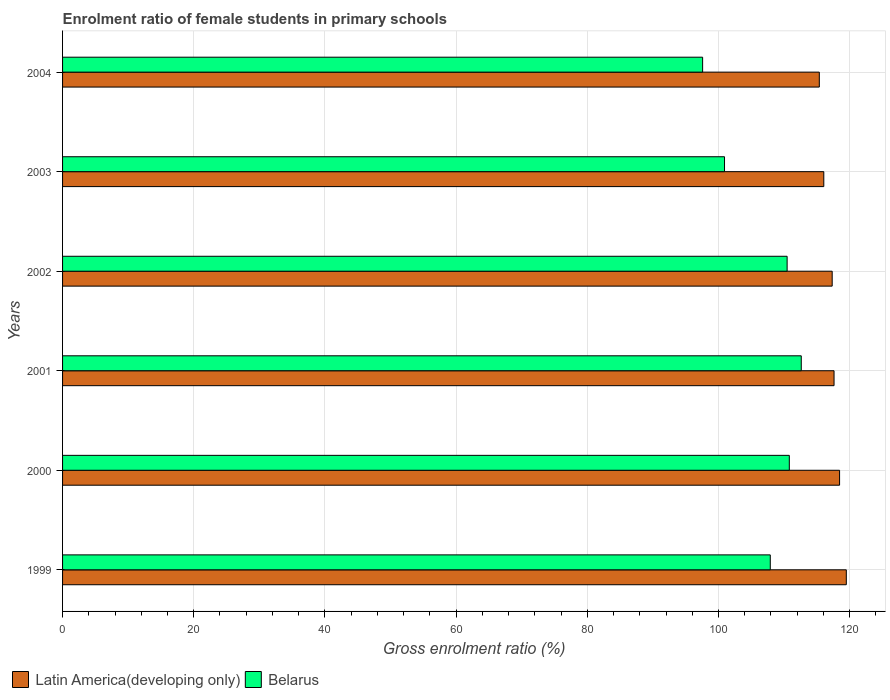Are the number of bars on each tick of the Y-axis equal?
Make the answer very short. Yes. How many bars are there on the 2nd tick from the bottom?
Keep it short and to the point. 2. What is the label of the 2nd group of bars from the top?
Your answer should be compact. 2003. In how many cases, is the number of bars for a given year not equal to the number of legend labels?
Your response must be concise. 0. What is the enrolment ratio of female students in primary schools in Belarus in 2003?
Keep it short and to the point. 100.92. Across all years, what is the maximum enrolment ratio of female students in primary schools in Belarus?
Provide a succinct answer. 112.62. Across all years, what is the minimum enrolment ratio of female students in primary schools in Latin America(developing only)?
Ensure brevity in your answer.  115.37. What is the total enrolment ratio of female students in primary schools in Latin America(developing only) in the graph?
Provide a succinct answer. 704.31. What is the difference between the enrolment ratio of female students in primary schools in Latin America(developing only) in 2000 and that in 2002?
Give a very brief answer. 1.13. What is the difference between the enrolment ratio of female students in primary schools in Belarus in 2004 and the enrolment ratio of female students in primary schools in Latin America(developing only) in 1999?
Give a very brief answer. -21.9. What is the average enrolment ratio of female students in primary schools in Belarus per year?
Your response must be concise. 106.71. In the year 2001, what is the difference between the enrolment ratio of female students in primary schools in Latin America(developing only) and enrolment ratio of female students in primary schools in Belarus?
Keep it short and to the point. 5. What is the ratio of the enrolment ratio of female students in primary schools in Belarus in 1999 to that in 2003?
Make the answer very short. 1.07. Is the difference between the enrolment ratio of female students in primary schools in Latin America(developing only) in 1999 and 2003 greater than the difference between the enrolment ratio of female students in primary schools in Belarus in 1999 and 2003?
Your answer should be compact. No. What is the difference between the highest and the second highest enrolment ratio of female students in primary schools in Belarus?
Your answer should be very brief. 1.82. What is the difference between the highest and the lowest enrolment ratio of female students in primary schools in Belarus?
Your response must be concise. 15.04. Is the sum of the enrolment ratio of female students in primary schools in Latin America(developing only) in 2000 and 2002 greater than the maximum enrolment ratio of female students in primary schools in Belarus across all years?
Keep it short and to the point. Yes. What does the 1st bar from the top in 2003 represents?
Provide a succinct answer. Belarus. What does the 2nd bar from the bottom in 2001 represents?
Your answer should be very brief. Belarus. How many years are there in the graph?
Provide a short and direct response. 6. Does the graph contain any zero values?
Provide a succinct answer. No. Where does the legend appear in the graph?
Your answer should be very brief. Bottom left. What is the title of the graph?
Your response must be concise. Enrolment ratio of female students in primary schools. What is the label or title of the X-axis?
Provide a short and direct response. Gross enrolment ratio (%). What is the label or title of the Y-axis?
Ensure brevity in your answer.  Years. What is the Gross enrolment ratio (%) in Latin America(developing only) in 1999?
Your response must be concise. 119.48. What is the Gross enrolment ratio (%) of Belarus in 1999?
Your answer should be very brief. 107.89. What is the Gross enrolment ratio (%) in Latin America(developing only) in 2000?
Offer a terse response. 118.46. What is the Gross enrolment ratio (%) in Belarus in 2000?
Make the answer very short. 110.8. What is the Gross enrolment ratio (%) in Latin America(developing only) in 2001?
Ensure brevity in your answer.  117.61. What is the Gross enrolment ratio (%) of Belarus in 2001?
Provide a succinct answer. 112.62. What is the Gross enrolment ratio (%) of Latin America(developing only) in 2002?
Ensure brevity in your answer.  117.33. What is the Gross enrolment ratio (%) in Belarus in 2002?
Give a very brief answer. 110.46. What is the Gross enrolment ratio (%) of Latin America(developing only) in 2003?
Offer a terse response. 116.05. What is the Gross enrolment ratio (%) of Belarus in 2003?
Ensure brevity in your answer.  100.92. What is the Gross enrolment ratio (%) in Latin America(developing only) in 2004?
Make the answer very short. 115.37. What is the Gross enrolment ratio (%) in Belarus in 2004?
Make the answer very short. 97.58. Across all years, what is the maximum Gross enrolment ratio (%) of Latin America(developing only)?
Offer a terse response. 119.48. Across all years, what is the maximum Gross enrolment ratio (%) in Belarus?
Make the answer very short. 112.62. Across all years, what is the minimum Gross enrolment ratio (%) of Latin America(developing only)?
Make the answer very short. 115.37. Across all years, what is the minimum Gross enrolment ratio (%) of Belarus?
Keep it short and to the point. 97.58. What is the total Gross enrolment ratio (%) of Latin America(developing only) in the graph?
Offer a terse response. 704.31. What is the total Gross enrolment ratio (%) in Belarus in the graph?
Give a very brief answer. 640.27. What is the difference between the Gross enrolment ratio (%) of Latin America(developing only) in 1999 and that in 2000?
Make the answer very short. 1.03. What is the difference between the Gross enrolment ratio (%) of Belarus in 1999 and that in 2000?
Provide a succinct answer. -2.9. What is the difference between the Gross enrolment ratio (%) in Latin America(developing only) in 1999 and that in 2001?
Provide a short and direct response. 1.87. What is the difference between the Gross enrolment ratio (%) in Belarus in 1999 and that in 2001?
Your response must be concise. -4.72. What is the difference between the Gross enrolment ratio (%) in Latin America(developing only) in 1999 and that in 2002?
Your answer should be very brief. 2.15. What is the difference between the Gross enrolment ratio (%) in Belarus in 1999 and that in 2002?
Keep it short and to the point. -2.57. What is the difference between the Gross enrolment ratio (%) of Latin America(developing only) in 1999 and that in 2003?
Give a very brief answer. 3.43. What is the difference between the Gross enrolment ratio (%) in Belarus in 1999 and that in 2003?
Keep it short and to the point. 6.98. What is the difference between the Gross enrolment ratio (%) in Latin America(developing only) in 1999 and that in 2004?
Provide a short and direct response. 4.12. What is the difference between the Gross enrolment ratio (%) in Belarus in 1999 and that in 2004?
Ensure brevity in your answer.  10.31. What is the difference between the Gross enrolment ratio (%) in Latin America(developing only) in 2000 and that in 2001?
Provide a short and direct response. 0.84. What is the difference between the Gross enrolment ratio (%) in Belarus in 2000 and that in 2001?
Offer a terse response. -1.82. What is the difference between the Gross enrolment ratio (%) of Latin America(developing only) in 2000 and that in 2002?
Offer a very short reply. 1.13. What is the difference between the Gross enrolment ratio (%) in Belarus in 2000 and that in 2002?
Give a very brief answer. 0.34. What is the difference between the Gross enrolment ratio (%) in Latin America(developing only) in 2000 and that in 2003?
Give a very brief answer. 2.4. What is the difference between the Gross enrolment ratio (%) of Belarus in 2000 and that in 2003?
Ensure brevity in your answer.  9.88. What is the difference between the Gross enrolment ratio (%) of Latin America(developing only) in 2000 and that in 2004?
Your answer should be very brief. 3.09. What is the difference between the Gross enrolment ratio (%) in Belarus in 2000 and that in 2004?
Your response must be concise. 13.22. What is the difference between the Gross enrolment ratio (%) of Latin America(developing only) in 2001 and that in 2002?
Provide a short and direct response. 0.28. What is the difference between the Gross enrolment ratio (%) in Belarus in 2001 and that in 2002?
Your response must be concise. 2.16. What is the difference between the Gross enrolment ratio (%) of Latin America(developing only) in 2001 and that in 2003?
Provide a succinct answer. 1.56. What is the difference between the Gross enrolment ratio (%) in Belarus in 2001 and that in 2003?
Ensure brevity in your answer.  11.7. What is the difference between the Gross enrolment ratio (%) of Latin America(developing only) in 2001 and that in 2004?
Offer a terse response. 2.25. What is the difference between the Gross enrolment ratio (%) in Belarus in 2001 and that in 2004?
Ensure brevity in your answer.  15.04. What is the difference between the Gross enrolment ratio (%) of Latin America(developing only) in 2002 and that in 2003?
Make the answer very short. 1.28. What is the difference between the Gross enrolment ratio (%) in Belarus in 2002 and that in 2003?
Provide a succinct answer. 9.54. What is the difference between the Gross enrolment ratio (%) of Latin America(developing only) in 2002 and that in 2004?
Your answer should be compact. 1.96. What is the difference between the Gross enrolment ratio (%) of Belarus in 2002 and that in 2004?
Provide a succinct answer. 12.88. What is the difference between the Gross enrolment ratio (%) of Latin America(developing only) in 2003 and that in 2004?
Provide a succinct answer. 0.68. What is the difference between the Gross enrolment ratio (%) in Belarus in 2003 and that in 2004?
Your answer should be very brief. 3.34. What is the difference between the Gross enrolment ratio (%) in Latin America(developing only) in 1999 and the Gross enrolment ratio (%) in Belarus in 2000?
Make the answer very short. 8.69. What is the difference between the Gross enrolment ratio (%) in Latin America(developing only) in 1999 and the Gross enrolment ratio (%) in Belarus in 2001?
Your response must be concise. 6.87. What is the difference between the Gross enrolment ratio (%) of Latin America(developing only) in 1999 and the Gross enrolment ratio (%) of Belarus in 2002?
Offer a terse response. 9.02. What is the difference between the Gross enrolment ratio (%) of Latin America(developing only) in 1999 and the Gross enrolment ratio (%) of Belarus in 2003?
Offer a very short reply. 18.57. What is the difference between the Gross enrolment ratio (%) of Latin America(developing only) in 1999 and the Gross enrolment ratio (%) of Belarus in 2004?
Your answer should be very brief. 21.9. What is the difference between the Gross enrolment ratio (%) in Latin America(developing only) in 2000 and the Gross enrolment ratio (%) in Belarus in 2001?
Give a very brief answer. 5.84. What is the difference between the Gross enrolment ratio (%) of Latin America(developing only) in 2000 and the Gross enrolment ratio (%) of Belarus in 2002?
Provide a succinct answer. 8. What is the difference between the Gross enrolment ratio (%) in Latin America(developing only) in 2000 and the Gross enrolment ratio (%) in Belarus in 2003?
Give a very brief answer. 17.54. What is the difference between the Gross enrolment ratio (%) in Latin America(developing only) in 2000 and the Gross enrolment ratio (%) in Belarus in 2004?
Make the answer very short. 20.88. What is the difference between the Gross enrolment ratio (%) of Latin America(developing only) in 2001 and the Gross enrolment ratio (%) of Belarus in 2002?
Your answer should be very brief. 7.15. What is the difference between the Gross enrolment ratio (%) in Latin America(developing only) in 2001 and the Gross enrolment ratio (%) in Belarus in 2003?
Ensure brevity in your answer.  16.7. What is the difference between the Gross enrolment ratio (%) of Latin America(developing only) in 2001 and the Gross enrolment ratio (%) of Belarus in 2004?
Provide a short and direct response. 20.03. What is the difference between the Gross enrolment ratio (%) in Latin America(developing only) in 2002 and the Gross enrolment ratio (%) in Belarus in 2003?
Your answer should be compact. 16.41. What is the difference between the Gross enrolment ratio (%) of Latin America(developing only) in 2002 and the Gross enrolment ratio (%) of Belarus in 2004?
Offer a very short reply. 19.75. What is the difference between the Gross enrolment ratio (%) in Latin America(developing only) in 2003 and the Gross enrolment ratio (%) in Belarus in 2004?
Make the answer very short. 18.47. What is the average Gross enrolment ratio (%) in Latin America(developing only) per year?
Keep it short and to the point. 117.39. What is the average Gross enrolment ratio (%) in Belarus per year?
Your answer should be very brief. 106.71. In the year 1999, what is the difference between the Gross enrolment ratio (%) in Latin America(developing only) and Gross enrolment ratio (%) in Belarus?
Offer a terse response. 11.59. In the year 2000, what is the difference between the Gross enrolment ratio (%) in Latin America(developing only) and Gross enrolment ratio (%) in Belarus?
Your answer should be compact. 7.66. In the year 2001, what is the difference between the Gross enrolment ratio (%) in Latin America(developing only) and Gross enrolment ratio (%) in Belarus?
Your response must be concise. 5. In the year 2002, what is the difference between the Gross enrolment ratio (%) of Latin America(developing only) and Gross enrolment ratio (%) of Belarus?
Provide a succinct answer. 6.87. In the year 2003, what is the difference between the Gross enrolment ratio (%) of Latin America(developing only) and Gross enrolment ratio (%) of Belarus?
Offer a terse response. 15.14. In the year 2004, what is the difference between the Gross enrolment ratio (%) of Latin America(developing only) and Gross enrolment ratio (%) of Belarus?
Your response must be concise. 17.79. What is the ratio of the Gross enrolment ratio (%) in Latin America(developing only) in 1999 to that in 2000?
Offer a very short reply. 1.01. What is the ratio of the Gross enrolment ratio (%) of Belarus in 1999 to that in 2000?
Your answer should be compact. 0.97. What is the ratio of the Gross enrolment ratio (%) of Latin America(developing only) in 1999 to that in 2001?
Offer a very short reply. 1.02. What is the ratio of the Gross enrolment ratio (%) in Belarus in 1999 to that in 2001?
Your answer should be compact. 0.96. What is the ratio of the Gross enrolment ratio (%) in Latin America(developing only) in 1999 to that in 2002?
Your response must be concise. 1.02. What is the ratio of the Gross enrolment ratio (%) in Belarus in 1999 to that in 2002?
Offer a very short reply. 0.98. What is the ratio of the Gross enrolment ratio (%) in Latin America(developing only) in 1999 to that in 2003?
Provide a short and direct response. 1.03. What is the ratio of the Gross enrolment ratio (%) of Belarus in 1999 to that in 2003?
Your response must be concise. 1.07. What is the ratio of the Gross enrolment ratio (%) of Latin America(developing only) in 1999 to that in 2004?
Offer a terse response. 1.04. What is the ratio of the Gross enrolment ratio (%) of Belarus in 1999 to that in 2004?
Offer a terse response. 1.11. What is the ratio of the Gross enrolment ratio (%) of Latin America(developing only) in 2000 to that in 2001?
Keep it short and to the point. 1.01. What is the ratio of the Gross enrolment ratio (%) in Belarus in 2000 to that in 2001?
Ensure brevity in your answer.  0.98. What is the ratio of the Gross enrolment ratio (%) of Latin America(developing only) in 2000 to that in 2002?
Make the answer very short. 1.01. What is the ratio of the Gross enrolment ratio (%) of Belarus in 2000 to that in 2002?
Give a very brief answer. 1. What is the ratio of the Gross enrolment ratio (%) in Latin America(developing only) in 2000 to that in 2003?
Make the answer very short. 1.02. What is the ratio of the Gross enrolment ratio (%) in Belarus in 2000 to that in 2003?
Ensure brevity in your answer.  1.1. What is the ratio of the Gross enrolment ratio (%) of Latin America(developing only) in 2000 to that in 2004?
Keep it short and to the point. 1.03. What is the ratio of the Gross enrolment ratio (%) in Belarus in 2000 to that in 2004?
Offer a terse response. 1.14. What is the ratio of the Gross enrolment ratio (%) of Belarus in 2001 to that in 2002?
Provide a succinct answer. 1.02. What is the ratio of the Gross enrolment ratio (%) in Latin America(developing only) in 2001 to that in 2003?
Make the answer very short. 1.01. What is the ratio of the Gross enrolment ratio (%) of Belarus in 2001 to that in 2003?
Provide a succinct answer. 1.12. What is the ratio of the Gross enrolment ratio (%) of Latin America(developing only) in 2001 to that in 2004?
Keep it short and to the point. 1.02. What is the ratio of the Gross enrolment ratio (%) of Belarus in 2001 to that in 2004?
Provide a succinct answer. 1.15. What is the ratio of the Gross enrolment ratio (%) of Belarus in 2002 to that in 2003?
Provide a short and direct response. 1.09. What is the ratio of the Gross enrolment ratio (%) in Latin America(developing only) in 2002 to that in 2004?
Keep it short and to the point. 1.02. What is the ratio of the Gross enrolment ratio (%) in Belarus in 2002 to that in 2004?
Your answer should be very brief. 1.13. What is the ratio of the Gross enrolment ratio (%) in Latin America(developing only) in 2003 to that in 2004?
Give a very brief answer. 1.01. What is the ratio of the Gross enrolment ratio (%) in Belarus in 2003 to that in 2004?
Your answer should be very brief. 1.03. What is the difference between the highest and the second highest Gross enrolment ratio (%) of Latin America(developing only)?
Offer a very short reply. 1.03. What is the difference between the highest and the second highest Gross enrolment ratio (%) in Belarus?
Ensure brevity in your answer.  1.82. What is the difference between the highest and the lowest Gross enrolment ratio (%) in Latin America(developing only)?
Give a very brief answer. 4.12. What is the difference between the highest and the lowest Gross enrolment ratio (%) in Belarus?
Your response must be concise. 15.04. 